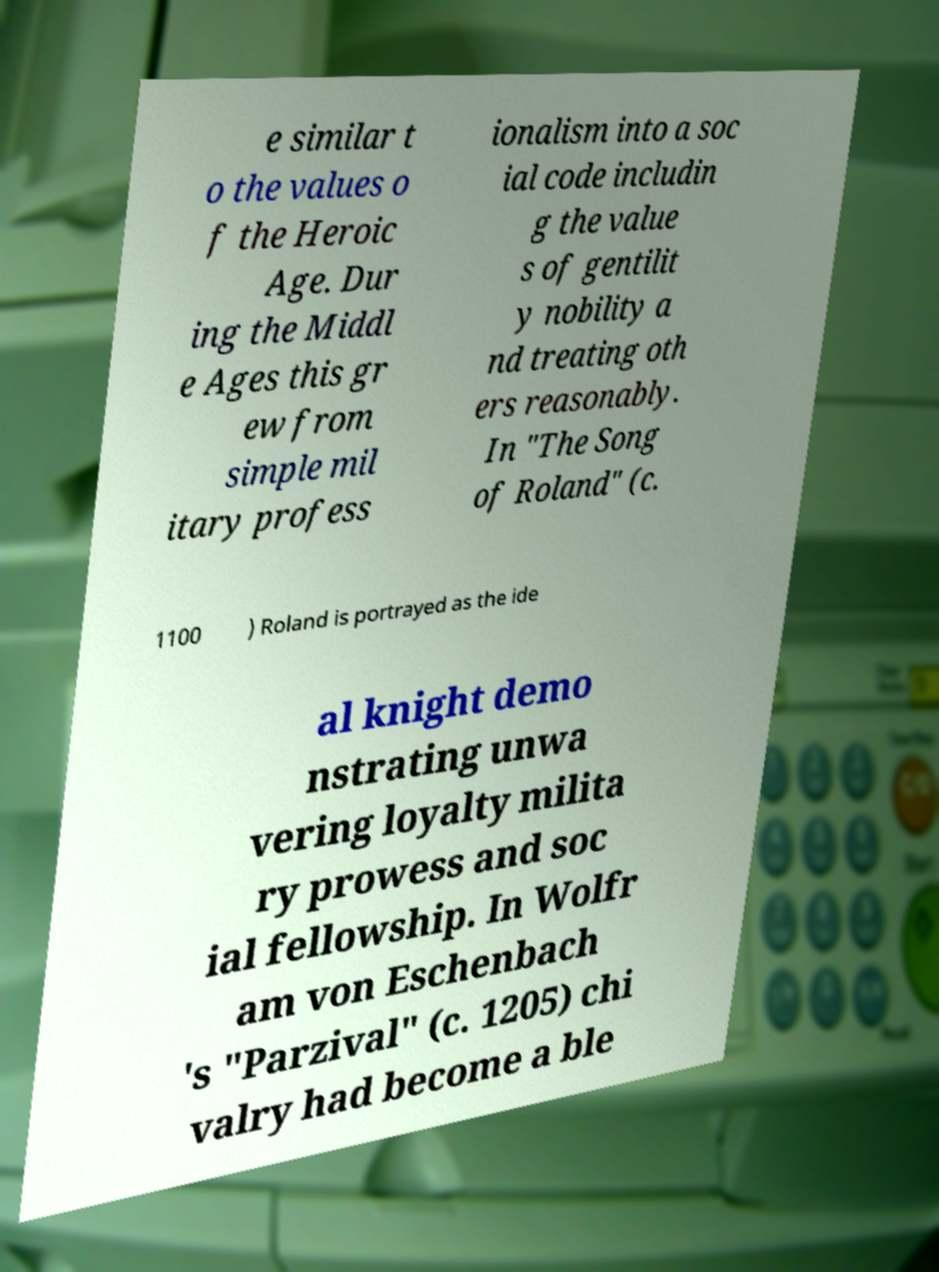Could you assist in decoding the text presented in this image and type it out clearly? e similar t o the values o f the Heroic Age. Dur ing the Middl e Ages this gr ew from simple mil itary profess ionalism into a soc ial code includin g the value s of gentilit y nobility a nd treating oth ers reasonably. In "The Song of Roland" (c. 1100 ) Roland is portrayed as the ide al knight demo nstrating unwa vering loyalty milita ry prowess and soc ial fellowship. In Wolfr am von Eschenbach 's "Parzival" (c. 1205) chi valry had become a ble 